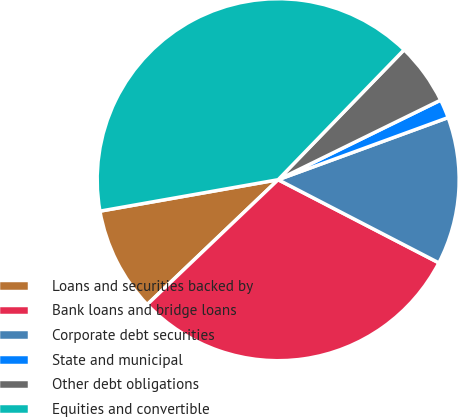Convert chart to OTSL. <chart><loc_0><loc_0><loc_500><loc_500><pie_chart><fcel>Loans and securities backed by<fcel>Bank loans and bridge loans<fcel>Corporate debt securities<fcel>State and municipal<fcel>Other debt obligations<fcel>Equities and convertible<nl><fcel>9.34%<fcel>30.28%<fcel>13.18%<fcel>1.67%<fcel>5.5%<fcel>40.03%<nl></chart> 